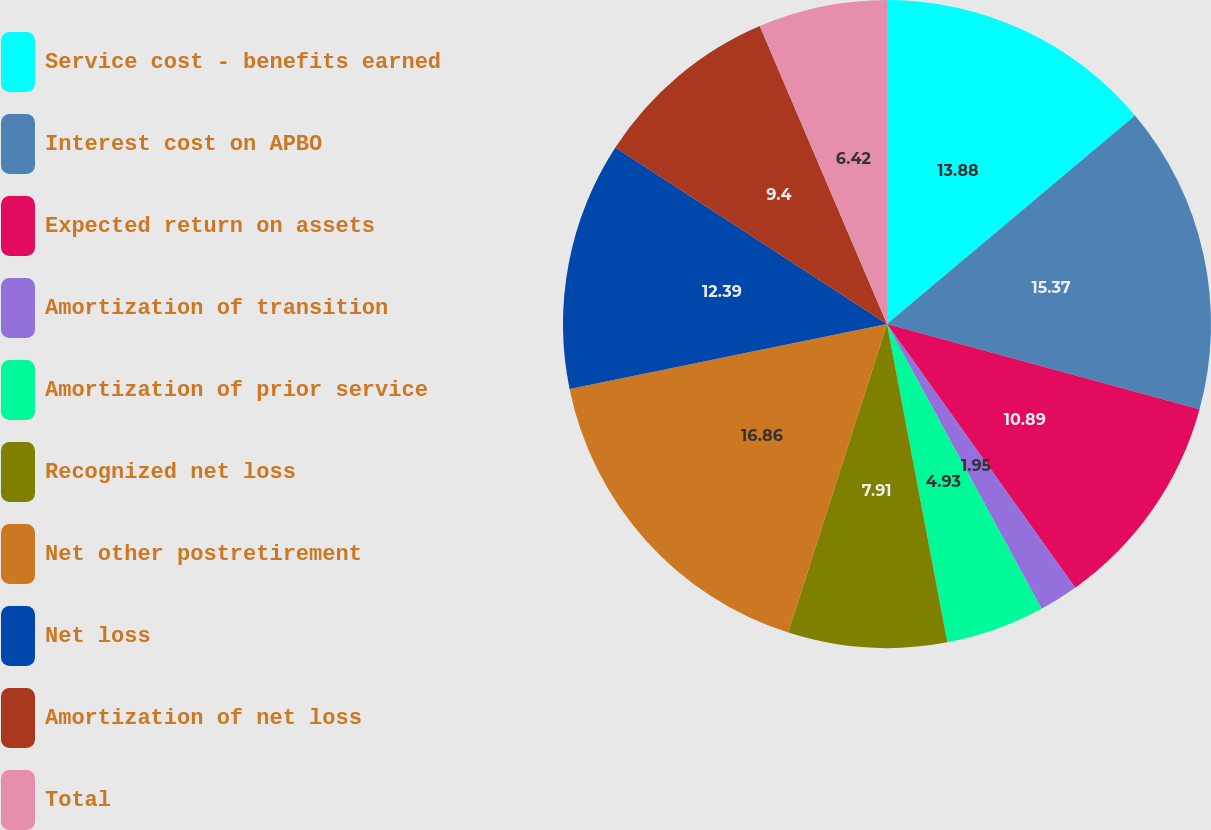Convert chart. <chart><loc_0><loc_0><loc_500><loc_500><pie_chart><fcel>Service cost - benefits earned<fcel>Interest cost on APBO<fcel>Expected return on assets<fcel>Amortization of transition<fcel>Amortization of prior service<fcel>Recognized net loss<fcel>Net other postretirement<fcel>Net loss<fcel>Amortization of net loss<fcel>Total<nl><fcel>13.87%<fcel>15.36%<fcel>10.89%<fcel>1.95%<fcel>4.93%<fcel>7.91%<fcel>16.85%<fcel>12.38%<fcel>9.4%<fcel>6.42%<nl></chart> 